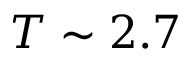<formula> <loc_0><loc_0><loc_500><loc_500>T \sim 2 . 7</formula> 